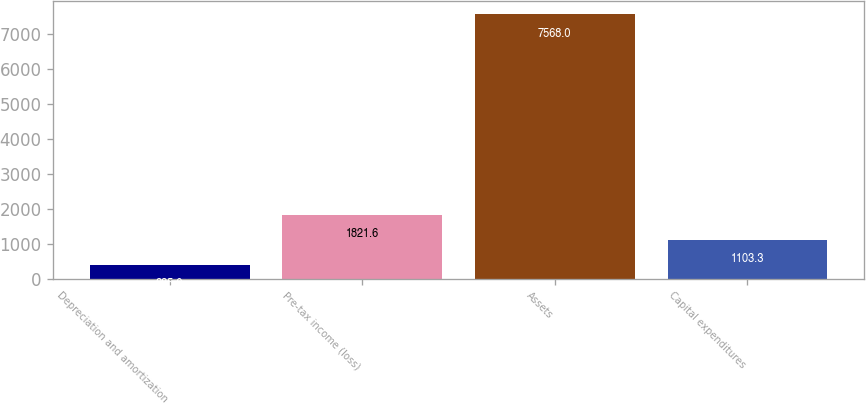Convert chart to OTSL. <chart><loc_0><loc_0><loc_500><loc_500><bar_chart><fcel>Depreciation and amortization<fcel>Pre-tax income (loss)<fcel>Assets<fcel>Capital expenditures<nl><fcel>385<fcel>1821.6<fcel>7568<fcel>1103.3<nl></chart> 